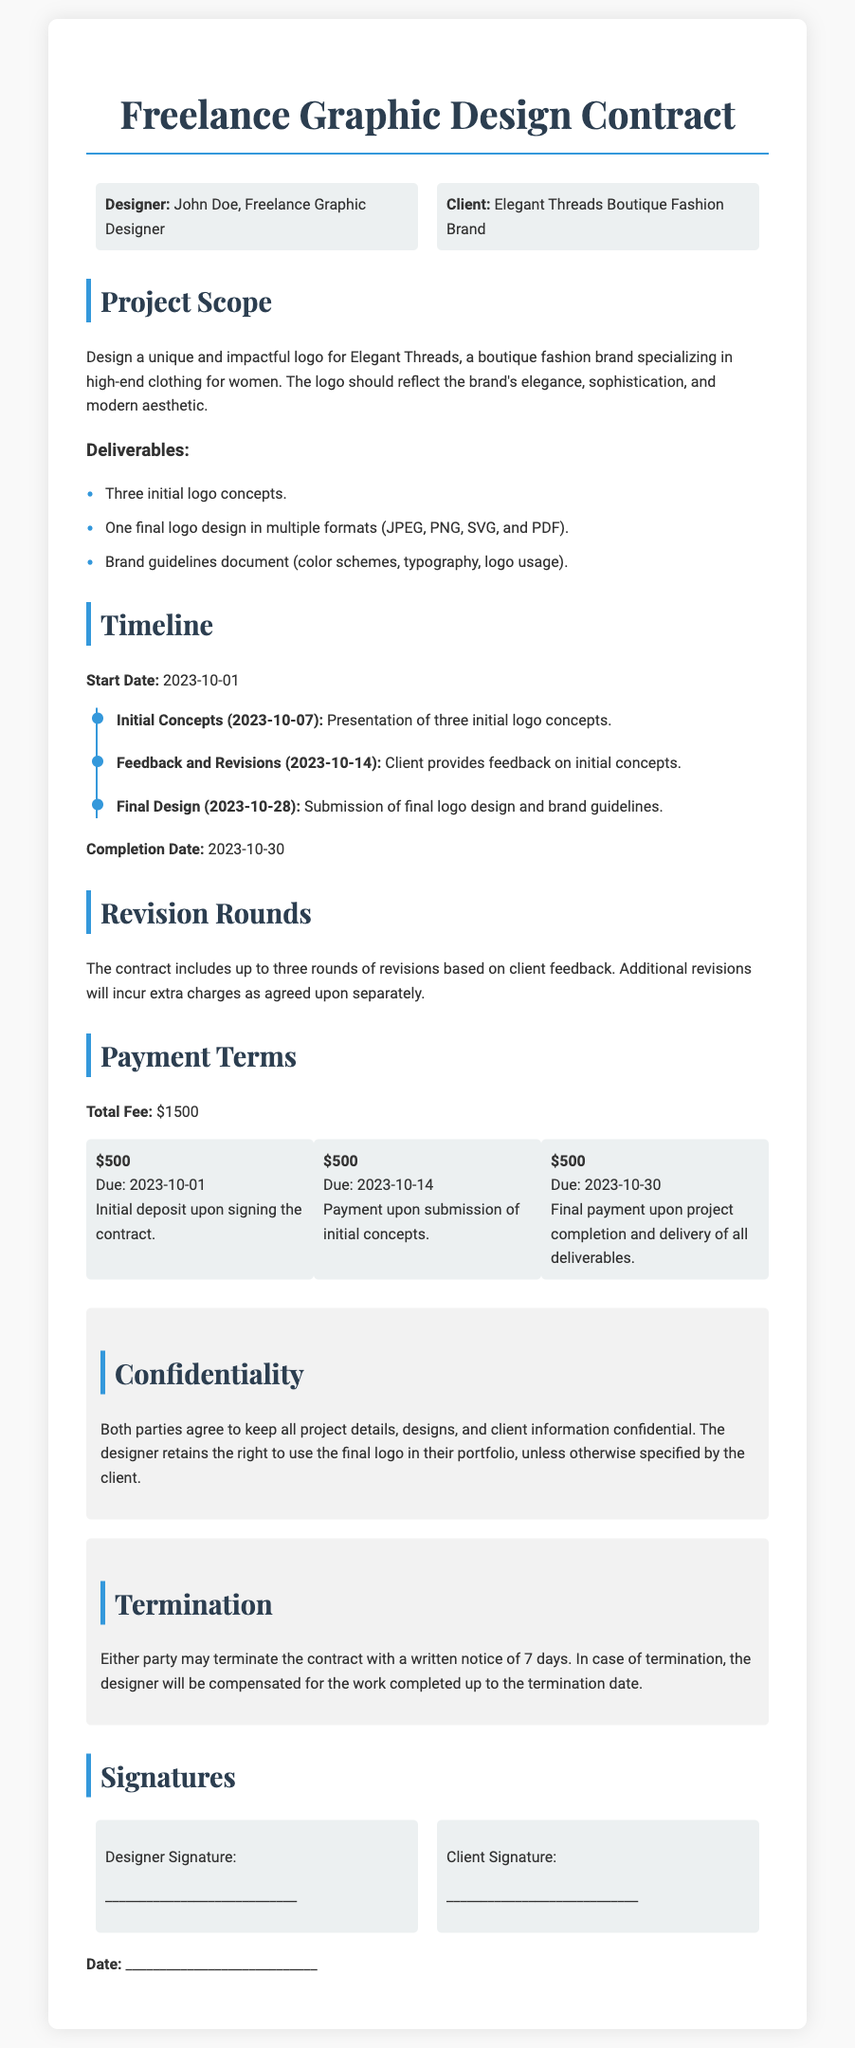What is the designer's name? The designer is identified as "John Doe" in the contract.
Answer: John Doe What is the client's name? The client is referred to as "Elegant Threads Boutique Fashion Brand" in the document.
Answer: Elegant Threads Boutique Fashion Brand What is the total fee for the design project? The total fee is specified in the document as the overall payment for the project.
Answer: $1500 How many initial logo concepts will be presented? The document states the number of logo concepts to be presented as part of the deliverables.
Answer: Three What is the completion date of the project? The contract mentions the completion date clearly, which marks the end of the project timeline.
Answer: 2023-10-30 What are the revision rounds included in the contract? The contract specifies how many rounds of revisions the client is entitled to based on feedback received.
Answer: Three What is the due date for the final payment? The final payment due date is provided alongside the payment schedule in the contract.
Answer: 2023-10-30 Is there a confidentiality clause in the contract? The document contains a section that addresses confidentiality between the designer and the client.
Answer: Yes What happens if either party wants to terminate the contract? The contract outlines the process that needs to be followed if either party wishes to terminate it.
Answer: Written notice of 7 days 